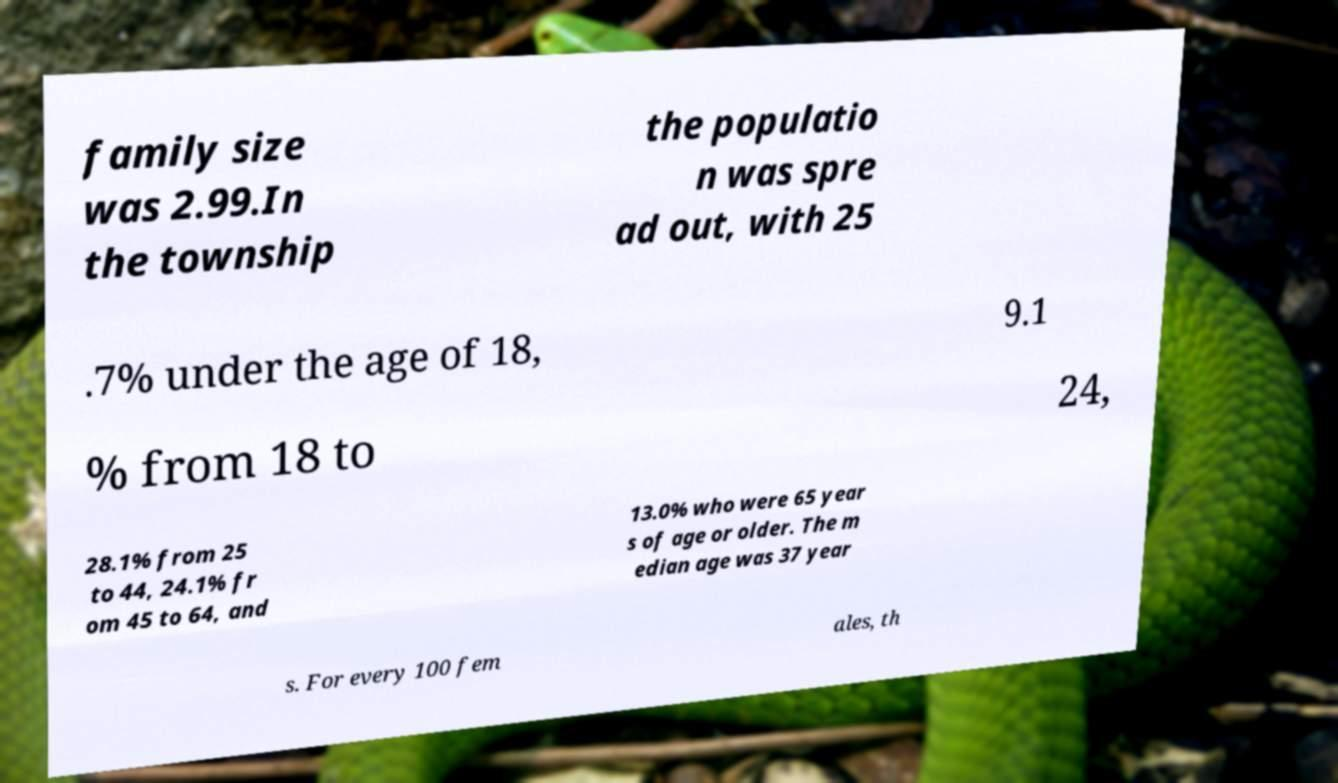For documentation purposes, I need the text within this image transcribed. Could you provide that? family size was 2.99.In the township the populatio n was spre ad out, with 25 .7% under the age of 18, 9.1 % from 18 to 24, 28.1% from 25 to 44, 24.1% fr om 45 to 64, and 13.0% who were 65 year s of age or older. The m edian age was 37 year s. For every 100 fem ales, th 